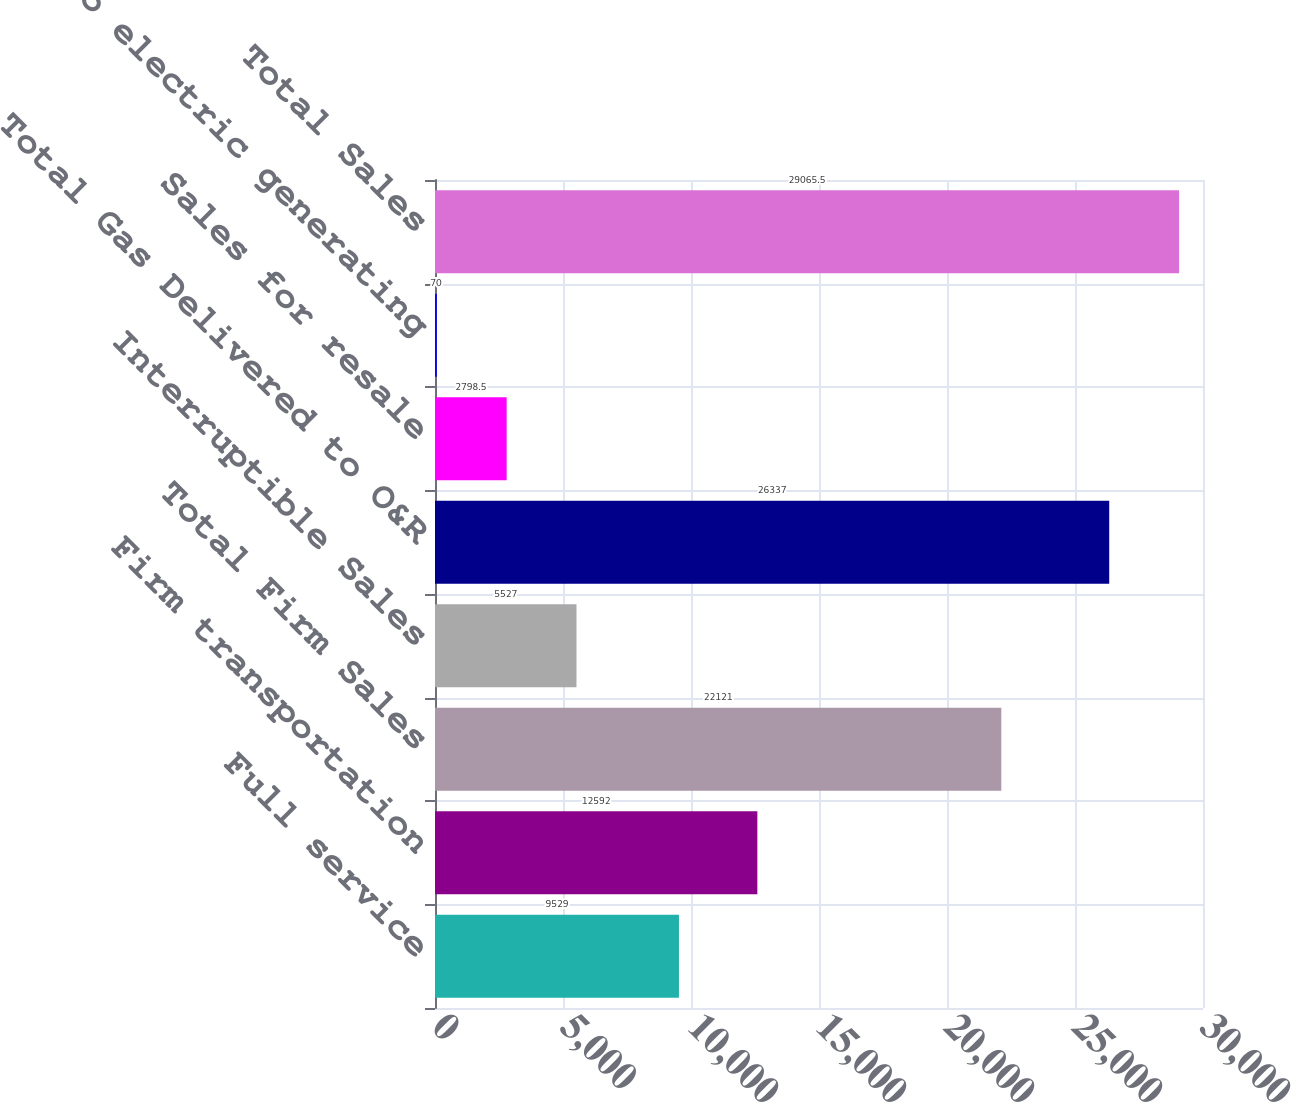Convert chart. <chart><loc_0><loc_0><loc_500><loc_500><bar_chart><fcel>Full service<fcel>Firm transportation<fcel>Total Firm Sales<fcel>Interruptible Sales<fcel>Total Gas Delivered to O&R<fcel>Sales for resale<fcel>Sales to electric generating<fcel>Total Sales<nl><fcel>9529<fcel>12592<fcel>22121<fcel>5527<fcel>26337<fcel>2798.5<fcel>70<fcel>29065.5<nl></chart> 